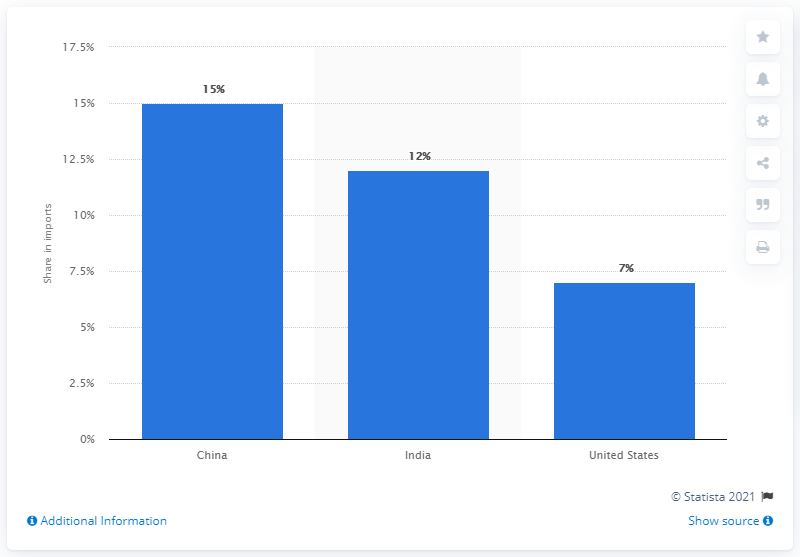List a handful of essential elements in this visual. The United Arab Emirates' main import partner in 2019 was China. 